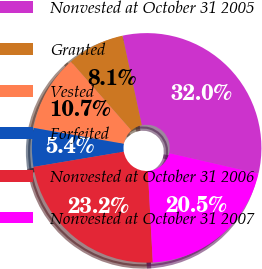Convert chart to OTSL. <chart><loc_0><loc_0><loc_500><loc_500><pie_chart><fcel>Nonvested at October 31 2005<fcel>Granted<fcel>Vested<fcel>Forfeited<fcel>Nonvested at October 31 2006<fcel>Nonvested at October 31 2007<nl><fcel>31.98%<fcel>8.09%<fcel>10.75%<fcel>5.44%<fcel>23.2%<fcel>20.55%<nl></chart> 